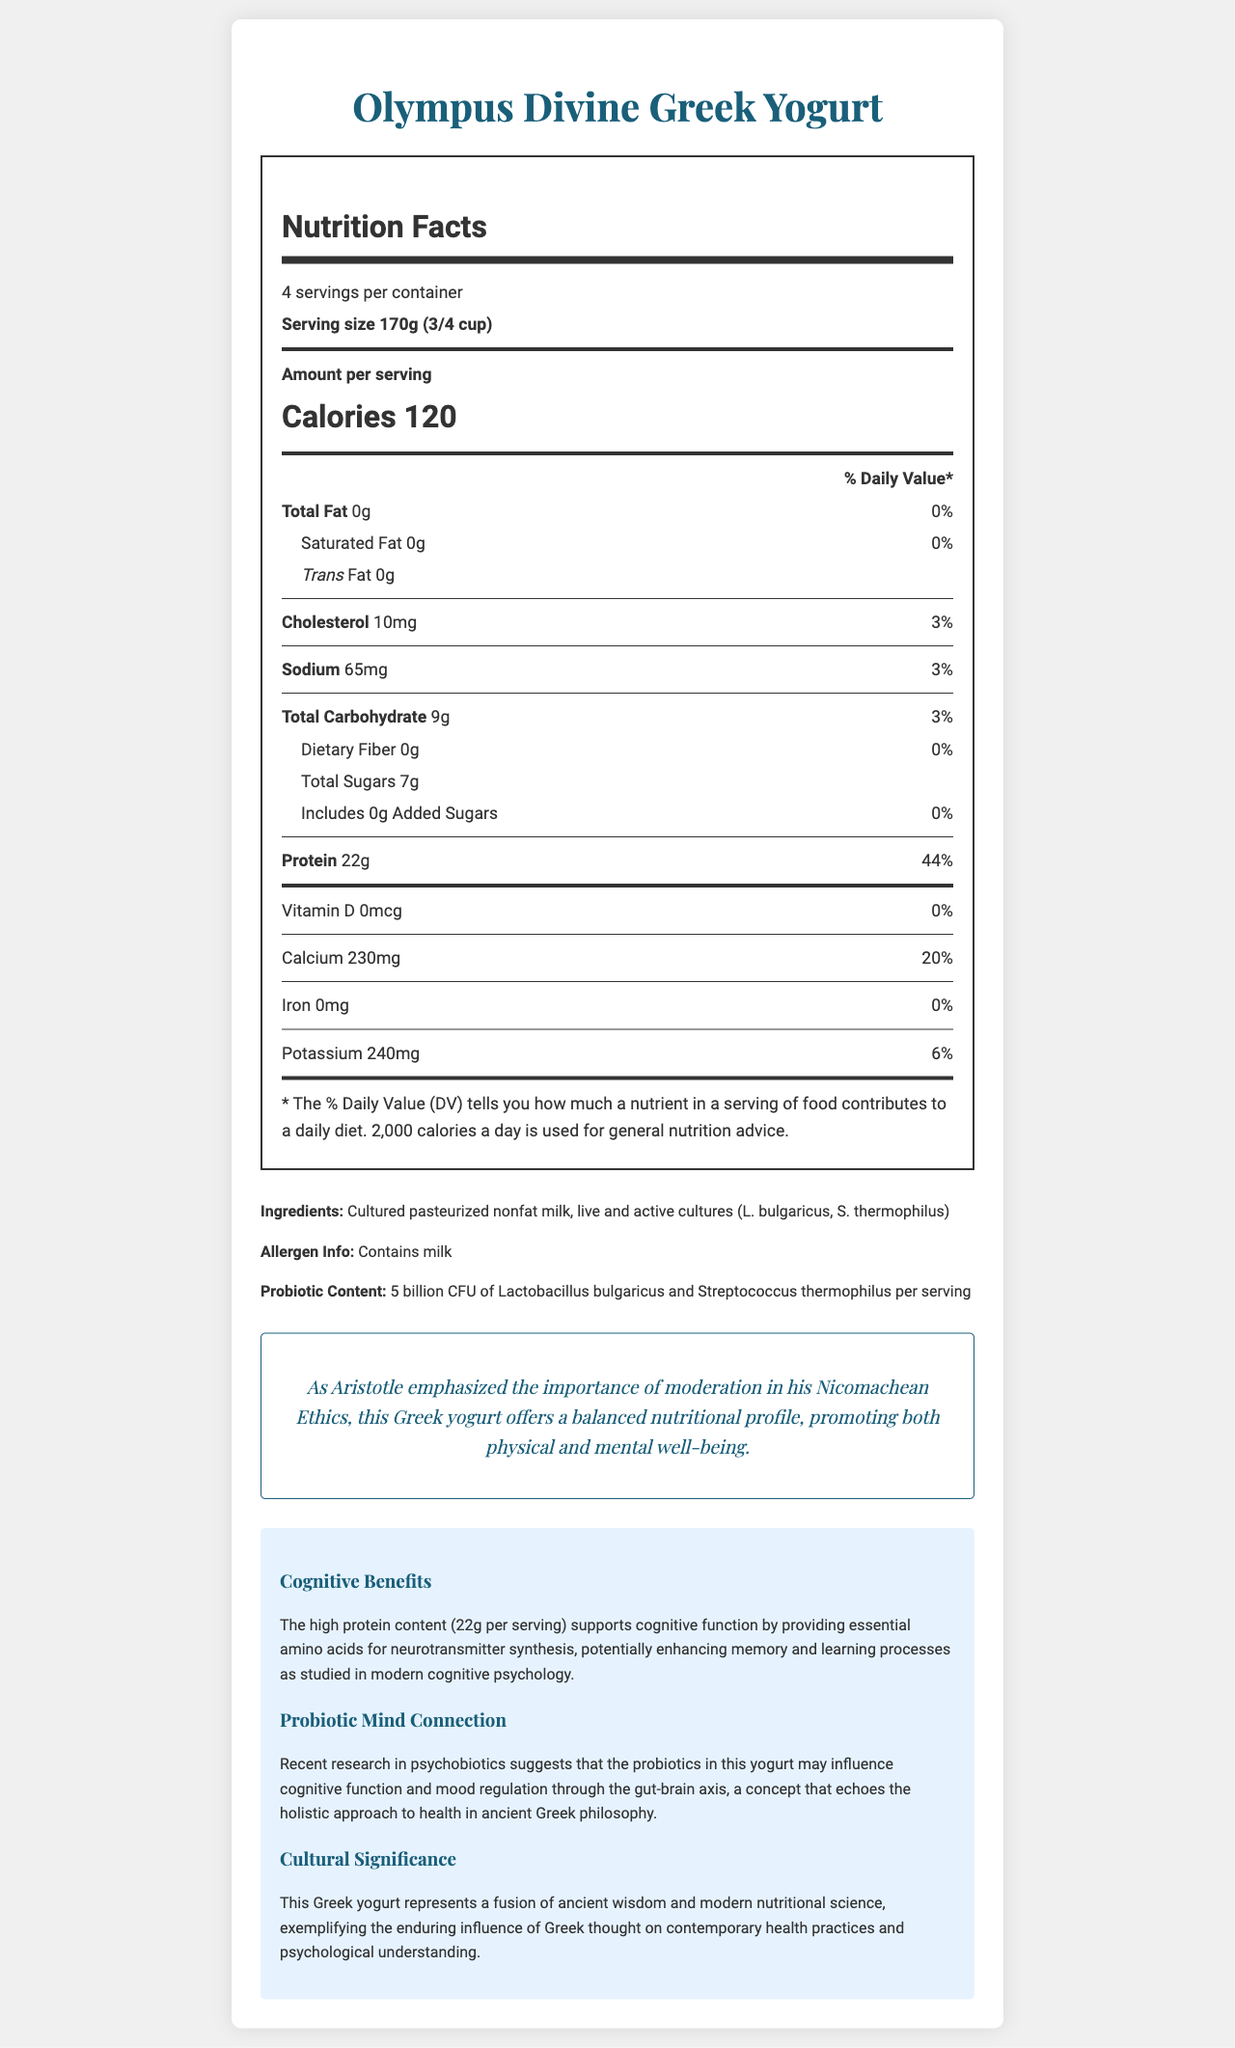what is the serving size? The serving size is listed near the top of the nutrition facts label: "Serving size 170g (3/4 cup)".
Answer: 170g (3/4 cup) how many calories are in one serving of Olympus Divine Greek Yogurt? The calories per serving are shown prominently in bold: "Calories 120".
Answer: 120 how much protein is there per serving? The protein content per serving is stated in the nutrition facts: "Protein 22g (44% daily value)".
Answer: 22g what is the probiotic content of the yogurt? The probiotic content is indicated under "Probiotic Content" in the main text.
Answer: 5 billion CFU of Lactobacillus bulgaricus and Streptococcus thermophilus per serving what is the daily value percentage of calcium in one serving? The daily value percentage of calcium is clearly mentioned: "Calcium 230mg (20% daily value)".
Answer: 20% which of the following nutrients does this yogurt contain? A. Vitamin C B. Calcium C. Iron D. Vitamin B12 The nutrition facts label mentions calcium but not the other options.
Answer: B how many grams of total fat are in one serving? A. 0g B. 5g C. 10g D. 15g The total fat content is listed as "Total Fat 0g (0% daily value)".
Answer: A is there any added sugar in Olympus Divine Greek Yogurt? The document states: "Includes 0g Added Sugars (0% daily value)".
Answer: No is this yogurt high in protein? With 22g of protein per serving (44% daily value), it is high in protein.
Answer: Yes summarize the benefits outlined in the document. The document provides a comprehensive overview of nutritional benefits, cognitive advantages tied to protein and probiotics, and cultural-philosophical insights linking ancient Greek wisdom to modern health practices.
Answer: Olympus Divine Greek Yogurt is high in protein and probiotics, with a balanced nutritional profile. It highlights philosophical connections to Aristotle's moderation and suggests cognitive benefits from its high protein content and probiotic influence on the gut-brain axis. The yogurt is also emblematic of the fusion of ancient Greek wisdom with modern nutritional science. what are the potential cognitive benefits mentioned? This information is discussed in the "Cognitive Benefits" section of the document.
Answer: The high protein content supports cognitive function by providing essential amino acids for neurotransmitter synthesis, potentially enhancing memory and learning processes. what key insight does Aristotle's philosophy provide according to the document? This is mentioned in the "Philosophical Insight" section.
Answer: The importance of moderation, as emphasized in his Nicomachean Ethics, which aligns with the balanced nutritional profile of the yogurt promoting both physical and mental well-being. how does the yogurt influence mood regulation according to the document? This is elaborated in the section "Probiotic Mind Connection".
Answer: Through the gut-brain axis, as suggested by recent research in psychobiotics, echoing the holistic approach to health in ancient Greek philosophy. what is the sodium content per serving? The sodium content per serving is clearly labeled: "Sodium 65mg (3% daily value)".
Answer: 65mg who manufactures this Greek yogurt? The document does not provide any information about the manufacturer.
Answer: Cannot be determined what ingredient could cause an allergic reaction? The allergen information states that the yogurt contains milk.
Answer: Milk 